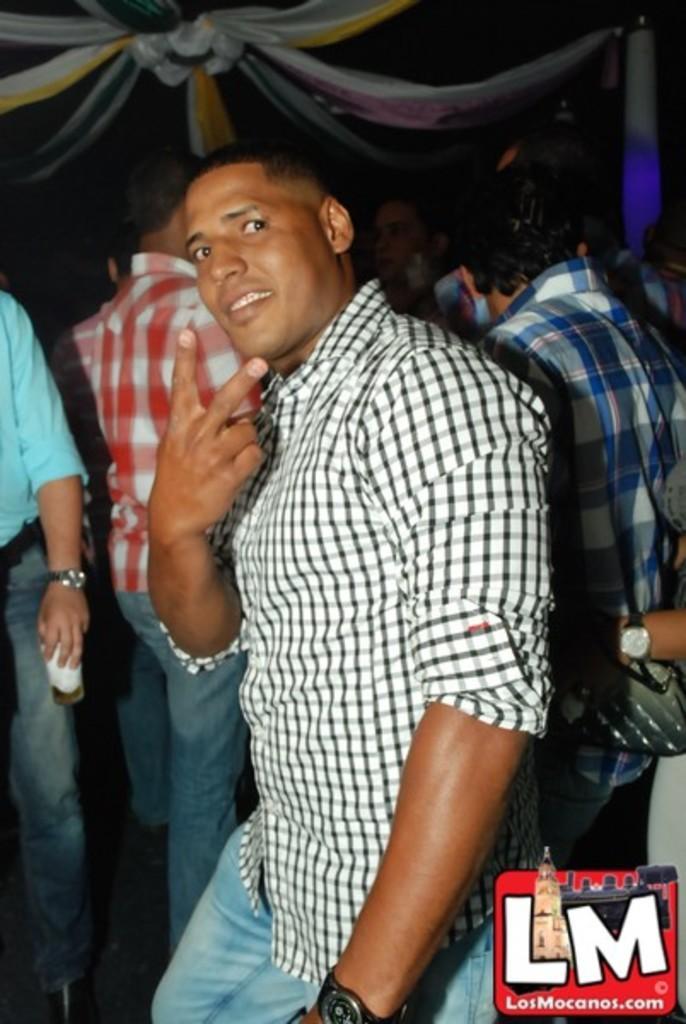Could you give a brief overview of what you see in this image? In this image we can see some people standing. On the backside we can see a person holding a glass and the roof is decorated with a cloth. 